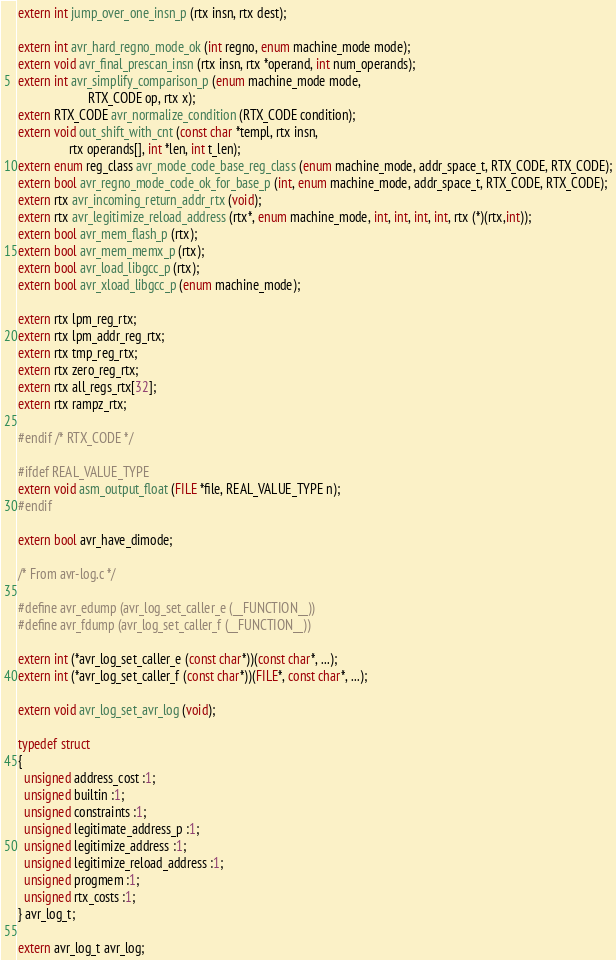Convert code to text. <code><loc_0><loc_0><loc_500><loc_500><_C_>extern int jump_over_one_insn_p (rtx insn, rtx dest);

extern int avr_hard_regno_mode_ok (int regno, enum machine_mode mode);
extern void avr_final_prescan_insn (rtx insn, rtx *operand, int num_operands);
extern int avr_simplify_comparison_p (enum machine_mode mode,
				      RTX_CODE op, rtx x);
extern RTX_CODE avr_normalize_condition (RTX_CODE condition);
extern void out_shift_with_cnt (const char *templ, rtx insn,
				rtx operands[], int *len, int t_len);
extern enum reg_class avr_mode_code_base_reg_class (enum machine_mode, addr_space_t, RTX_CODE, RTX_CODE);
extern bool avr_regno_mode_code_ok_for_base_p (int, enum machine_mode, addr_space_t, RTX_CODE, RTX_CODE);
extern rtx avr_incoming_return_addr_rtx (void);
extern rtx avr_legitimize_reload_address (rtx*, enum machine_mode, int, int, int, int, rtx (*)(rtx,int));
extern bool avr_mem_flash_p (rtx);
extern bool avr_mem_memx_p (rtx);
extern bool avr_load_libgcc_p (rtx);
extern bool avr_xload_libgcc_p (enum machine_mode);

extern rtx lpm_reg_rtx;
extern rtx lpm_addr_reg_rtx;
extern rtx tmp_reg_rtx;
extern rtx zero_reg_rtx;
extern rtx all_regs_rtx[32];
extern rtx rampz_rtx;

#endif /* RTX_CODE */

#ifdef REAL_VALUE_TYPE
extern void asm_output_float (FILE *file, REAL_VALUE_TYPE n);
#endif

extern bool avr_have_dimode;

/* From avr-log.c */

#define avr_edump (avr_log_set_caller_e (__FUNCTION__))
#define avr_fdump (avr_log_set_caller_f (__FUNCTION__))

extern int (*avr_log_set_caller_e (const char*))(const char*, ...);
extern int (*avr_log_set_caller_f (const char*))(FILE*, const char*, ...);

extern void avr_log_set_avr_log (void);

typedef struct
{
  unsigned address_cost :1;
  unsigned builtin :1;
  unsigned constraints :1;
  unsigned legitimate_address_p :1;
  unsigned legitimize_address :1;
  unsigned legitimize_reload_address :1;
  unsigned progmem :1;
  unsigned rtx_costs :1;
} avr_log_t;

extern avr_log_t avr_log;
</code> 